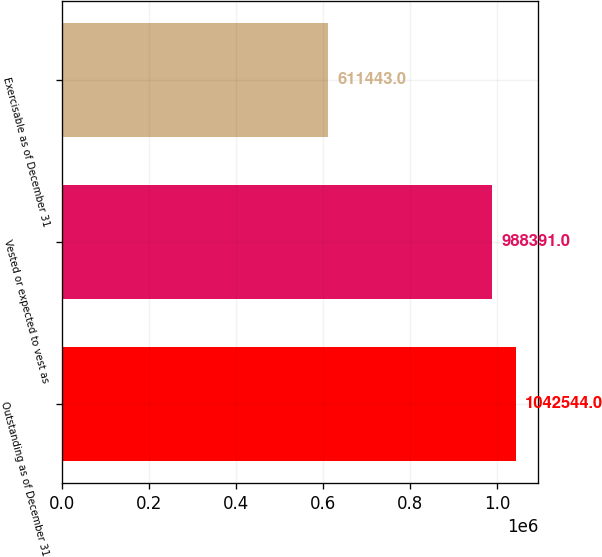Convert chart. <chart><loc_0><loc_0><loc_500><loc_500><bar_chart><fcel>Outstanding as of December 31<fcel>Vested or expected to vest as<fcel>Exercisable as of December 31<nl><fcel>1.04254e+06<fcel>988391<fcel>611443<nl></chart> 